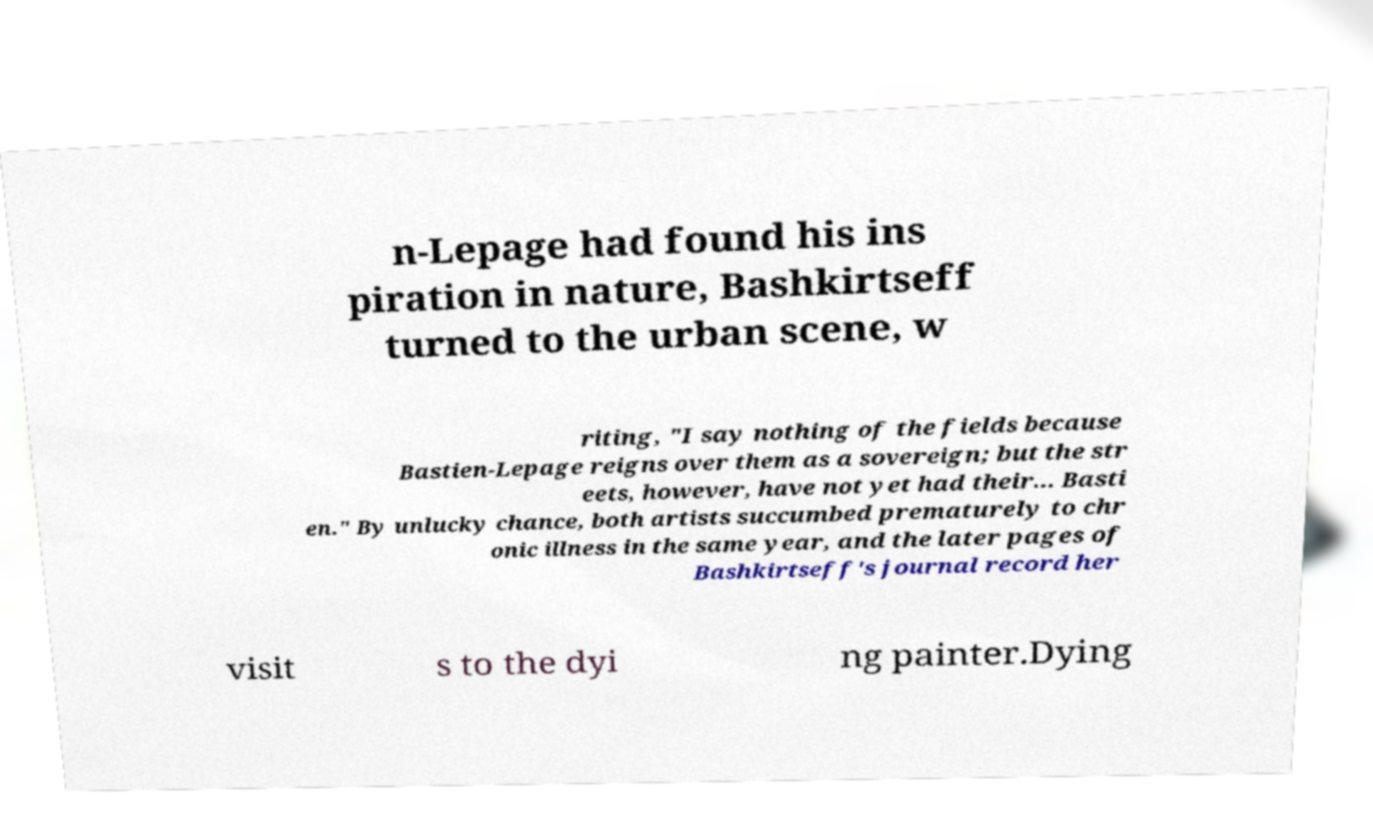What messages or text are displayed in this image? I need them in a readable, typed format. n-Lepage had found his ins piration in nature, Bashkirtseff turned to the urban scene, w riting, "I say nothing of the fields because Bastien-Lepage reigns over them as a sovereign; but the str eets, however, have not yet had their... Basti en." By unlucky chance, both artists succumbed prematurely to chr onic illness in the same year, and the later pages of Bashkirtseff's journal record her visit s to the dyi ng painter.Dying 